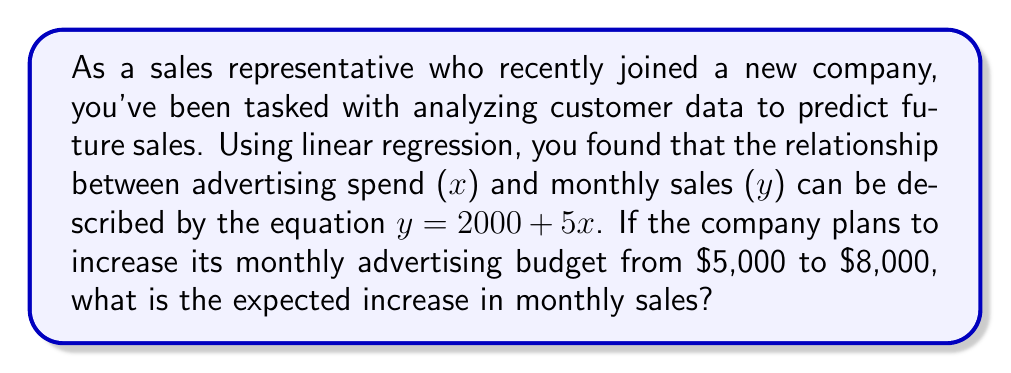Show me your answer to this math problem. Let's approach this step-by-step:

1) The linear regression equation is given as:
   $y = 2000 + 5x$
   Where $y$ is monthly sales and $x$ is advertising spend.

2) To find the increase in sales, we need to calculate the difference between sales at $8,000 advertising spend and $5,000 advertising spend.

3) For $x = 5000$ (current spend):
   $y_1 = 2000 + 5(5000) = 2000 + 25000 = 27000$

4) For $x = 8000$ (new spend):
   $y_2 = 2000 + 5(8000) = 2000 + 40000 = 42000$

5) The increase in sales is the difference between these two values:
   $\text{Increase} = y_2 - y_1 = 42000 - 27000 = 15000$

Therefore, the expected increase in monthly sales is $15,000.
Answer: $15,000 